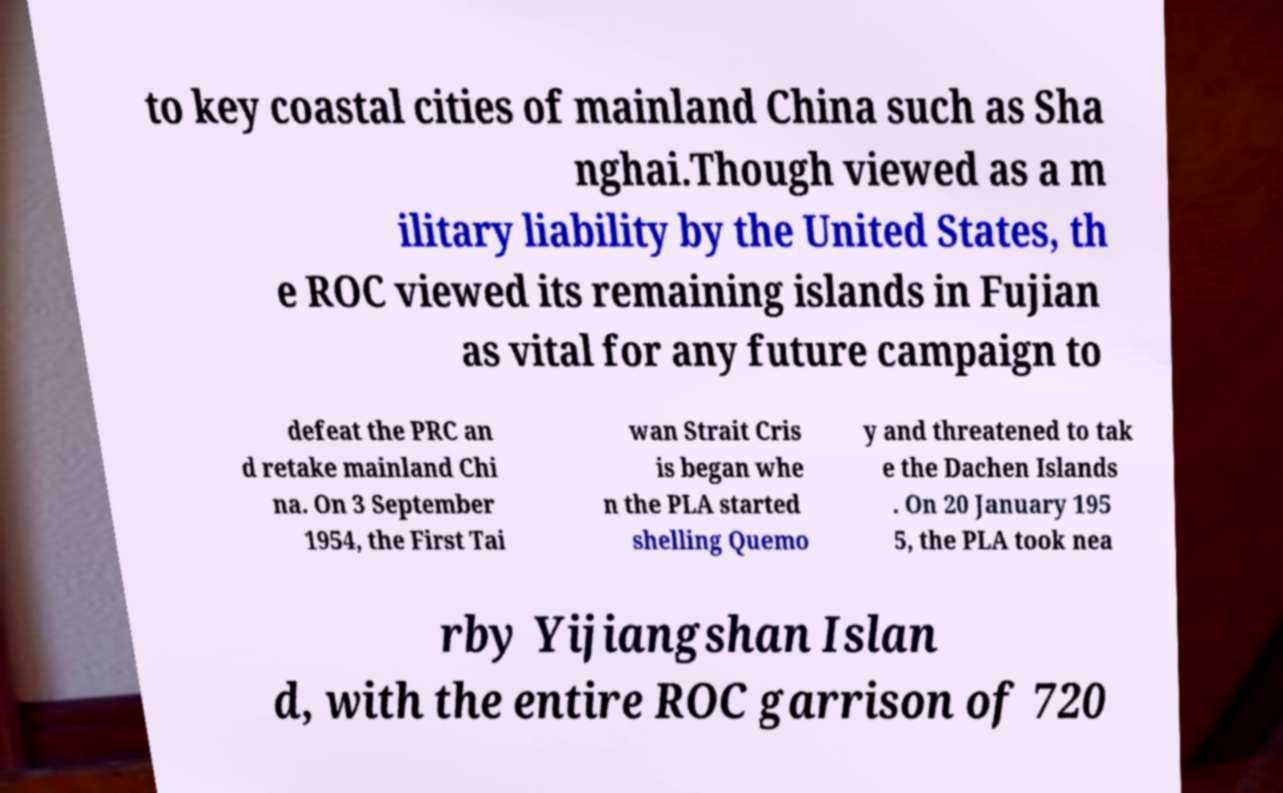Could you assist in decoding the text presented in this image and type it out clearly? to key coastal cities of mainland China such as Sha nghai.Though viewed as a m ilitary liability by the United States, th e ROC viewed its remaining islands in Fujian as vital for any future campaign to defeat the PRC an d retake mainland Chi na. On 3 September 1954, the First Tai wan Strait Cris is began whe n the PLA started shelling Quemo y and threatened to tak e the Dachen Islands . On 20 January 195 5, the PLA took nea rby Yijiangshan Islan d, with the entire ROC garrison of 720 